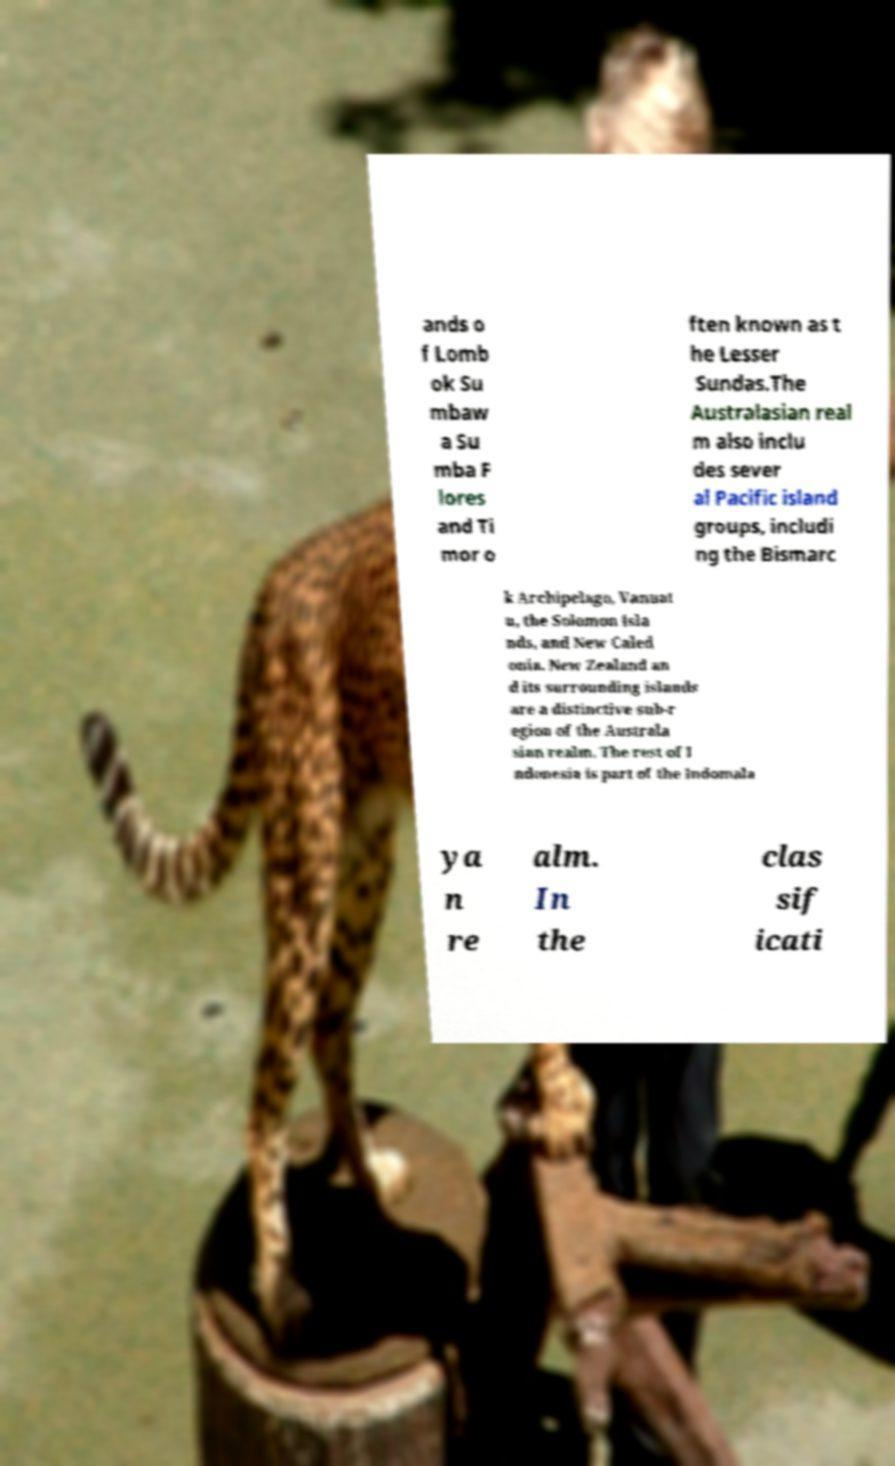Please read and relay the text visible in this image. What does it say? ands o f Lomb ok Su mbaw a Su mba F lores and Ti mor o ften known as t he Lesser Sundas.The Australasian real m also inclu des sever al Pacific island groups, includi ng the Bismarc k Archipelago, Vanuat u, the Solomon Isla nds, and New Caled onia. New Zealand an d its surrounding islands are a distinctive sub-r egion of the Australa sian realm. The rest of I ndonesia is part of the Indomala ya n re alm. In the clas sif icati 